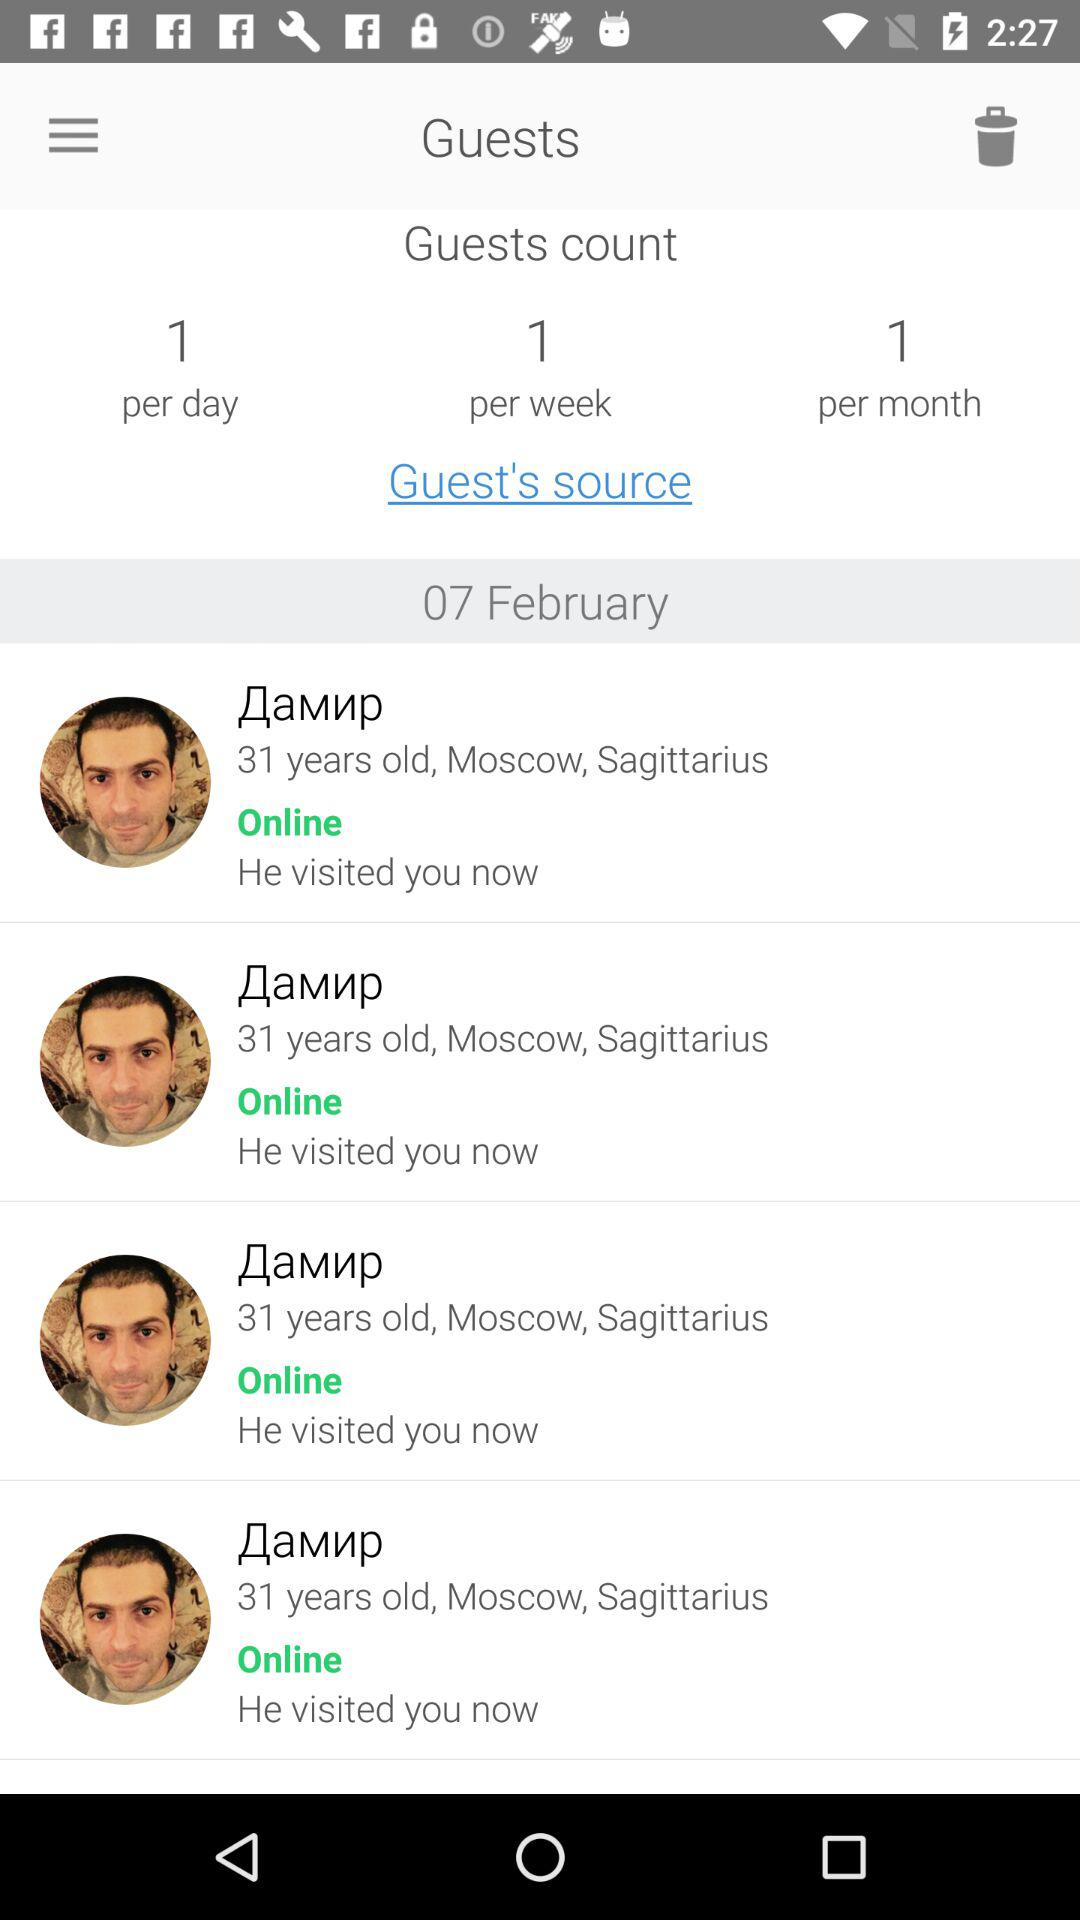What is the guest count per month? The guest count per month is 1. 